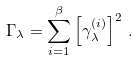Convert formula to latex. <formula><loc_0><loc_0><loc_500><loc_500>\Gamma _ { \lambda } = \sum _ { i = 1 } ^ { \beta } \left [ \gamma _ { \lambda } ^ { ( i ) } \right ] ^ { 2 } \, .</formula> 